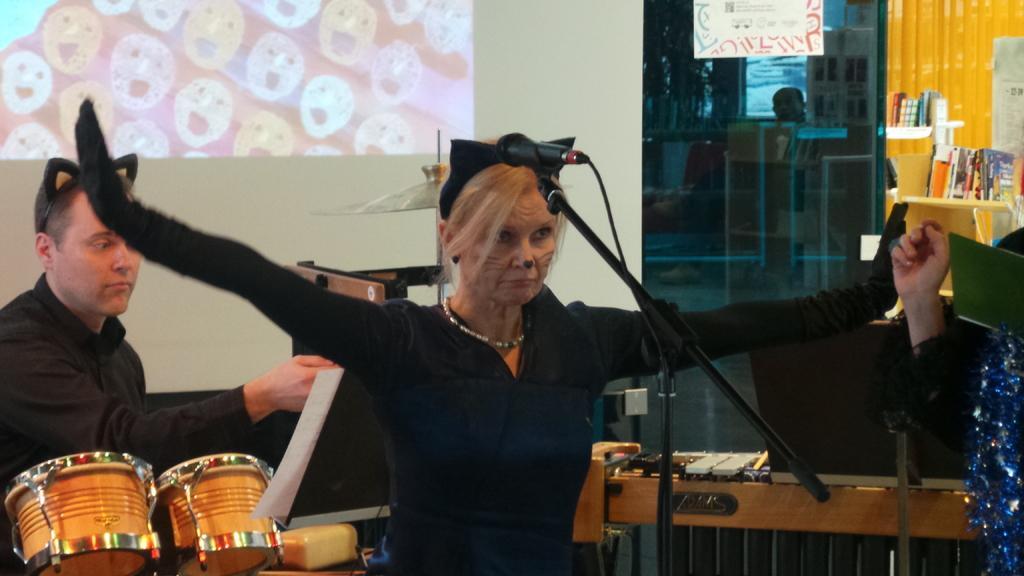Could you give a brief overview of what you see in this image? A person is standing wearing a black dress and a black hair band. There is a microphone at the front. A person is standing at the right. A person is sitting at the left and there are drums. At the right back there are books. 